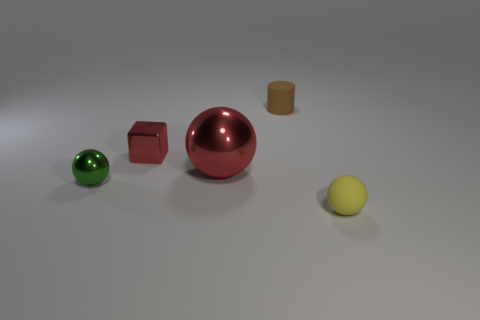Are there any other things that are the same shape as the big object?
Your answer should be very brief. Yes. There is a red object that is on the right side of the red thing behind the big sphere; is there a tiny brown rubber cylinder that is left of it?
Give a very brief answer. No. How many tiny brown objects have the same material as the green ball?
Offer a terse response. 0. There is a red thing that is in front of the tiny metallic cube; is its size the same as the sphere that is in front of the green ball?
Your answer should be very brief. No. The small rubber thing on the left side of the yellow matte object that is in front of the red object that is behind the large red object is what color?
Ensure brevity in your answer.  Brown. Are there any tiny yellow things that have the same shape as the small red object?
Your answer should be compact. No. Are there the same number of tiny brown things on the left side of the small green metallic sphere and tiny balls behind the cylinder?
Keep it short and to the point. Yes. There is a thing in front of the tiny green shiny ball; is its shape the same as the brown matte thing?
Your answer should be very brief. No. Does the tiny yellow thing have the same shape as the small brown thing?
Your response must be concise. No. How many shiny objects are either tiny green things or small gray balls?
Provide a short and direct response. 1. 